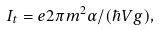<formula> <loc_0><loc_0><loc_500><loc_500>I _ { t } = e 2 \pi m ^ { 2 } \alpha / ( \hbar { V } g ) ,</formula> 